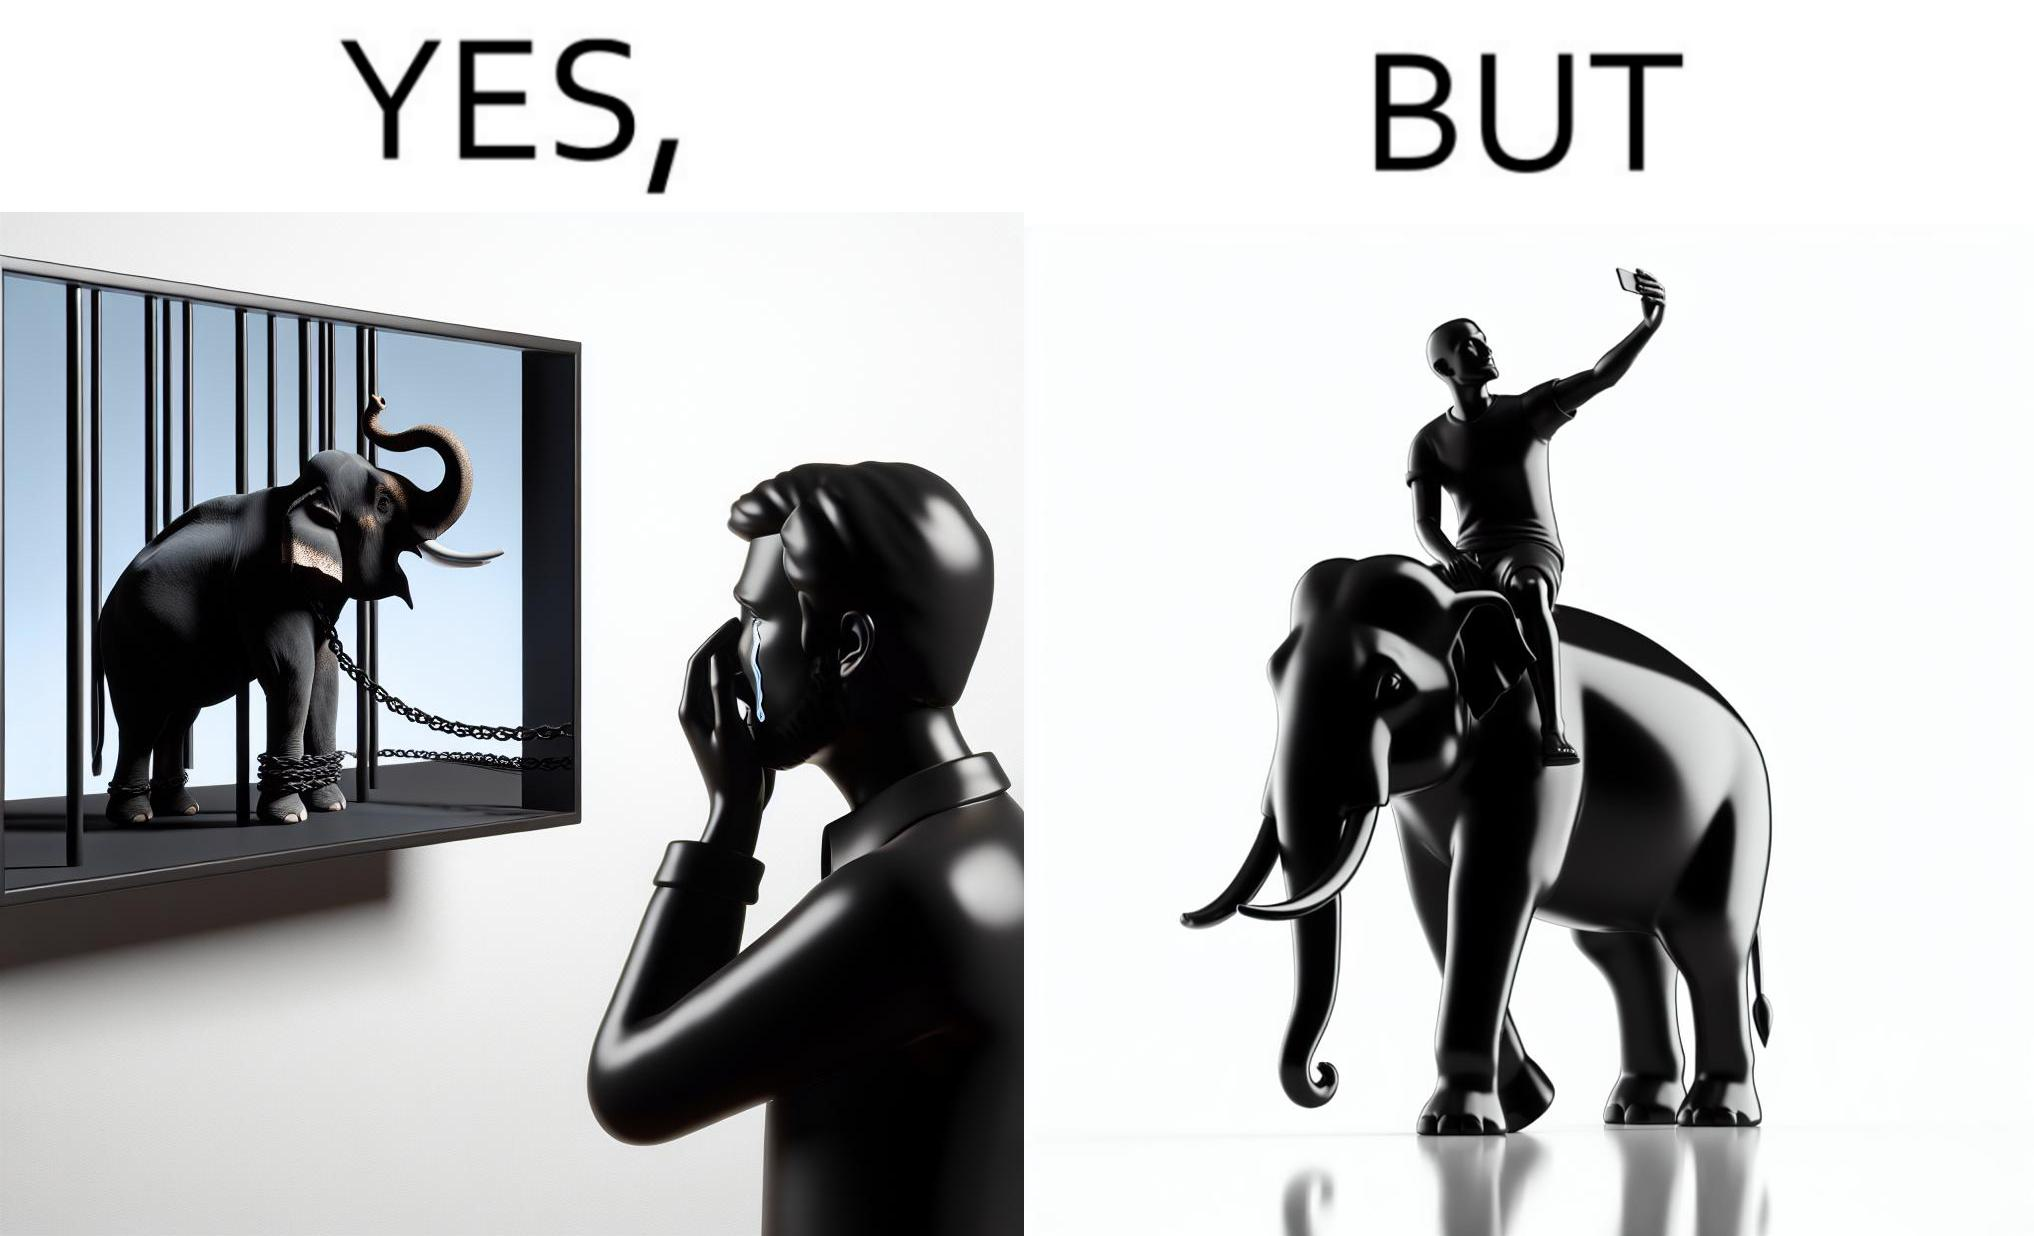Describe what you see in the left and right parts of this image. In the left part of the image: a man crying on seeing an elephant being chained in a cage in a TV program In the right part of the image: a person riding an elephant while taking selfies 